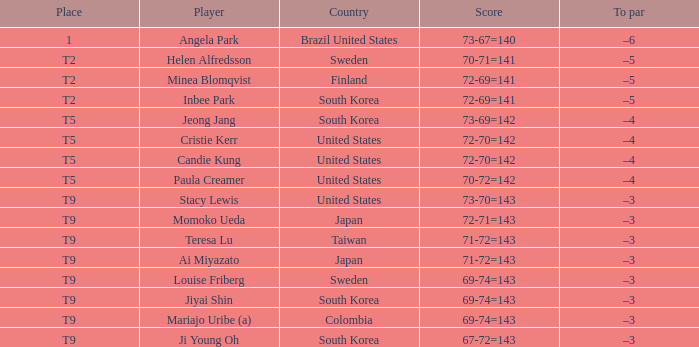Who scored 69-74=143 for Colombia? Mariajo Uribe (a). 